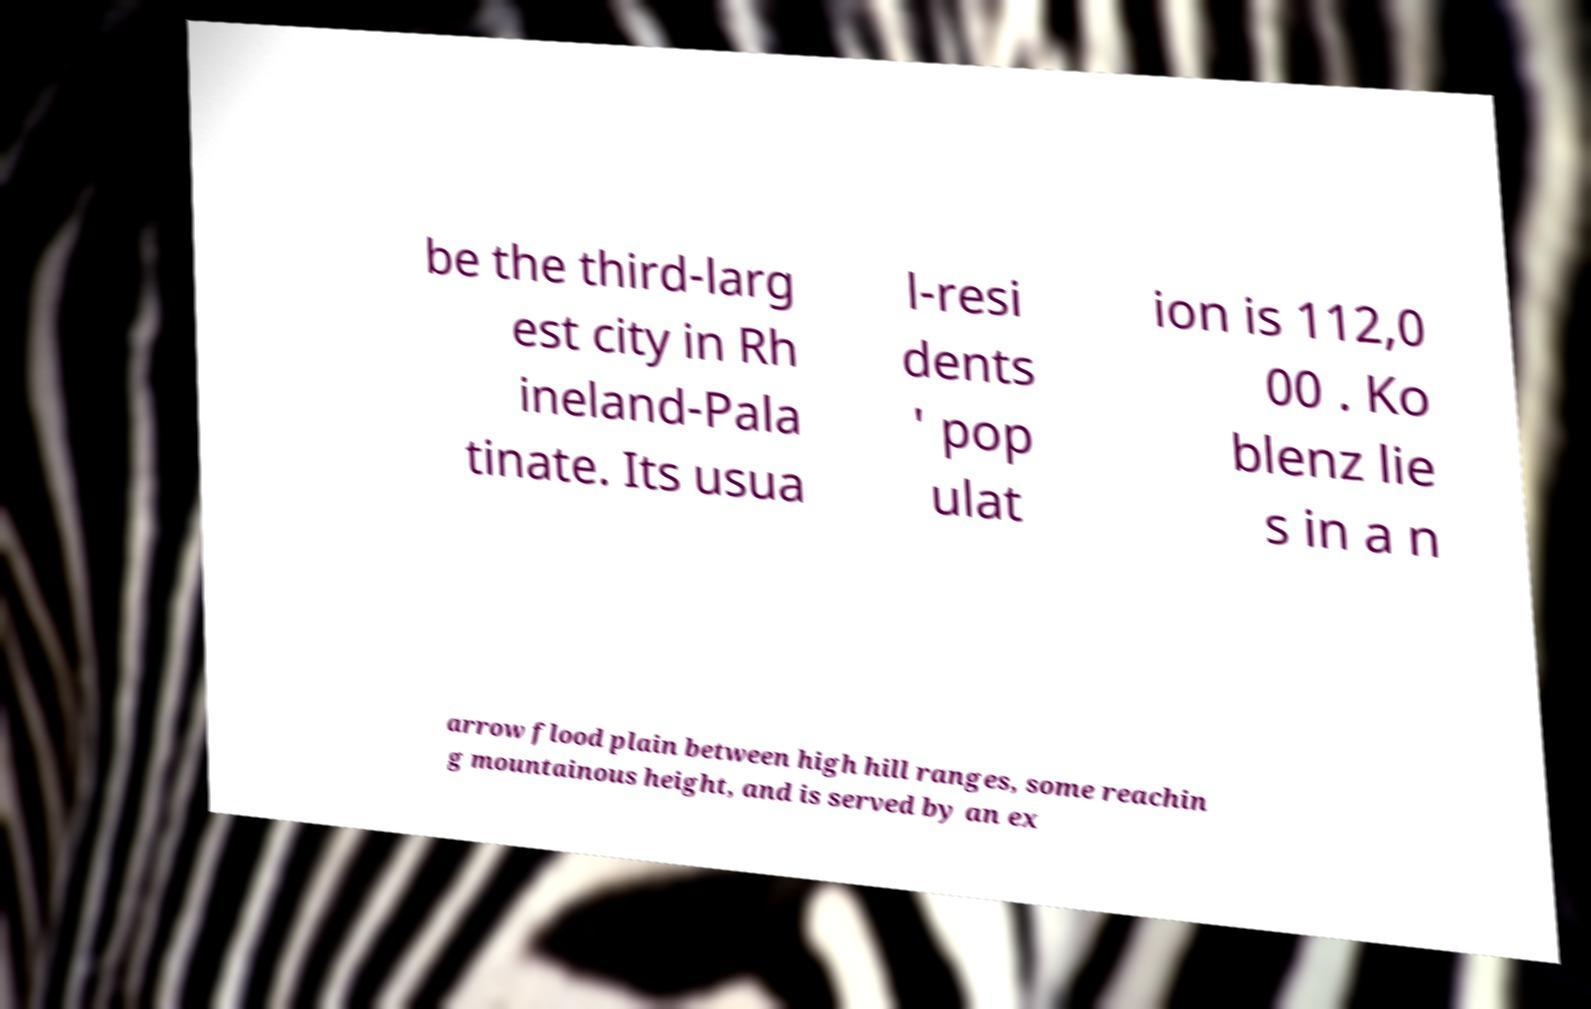I need the written content from this picture converted into text. Can you do that? be the third-larg est city in Rh ineland-Pala tinate. Its usua l-resi dents ' pop ulat ion is 112,0 00 . Ko blenz lie s in a n arrow flood plain between high hill ranges, some reachin g mountainous height, and is served by an ex 